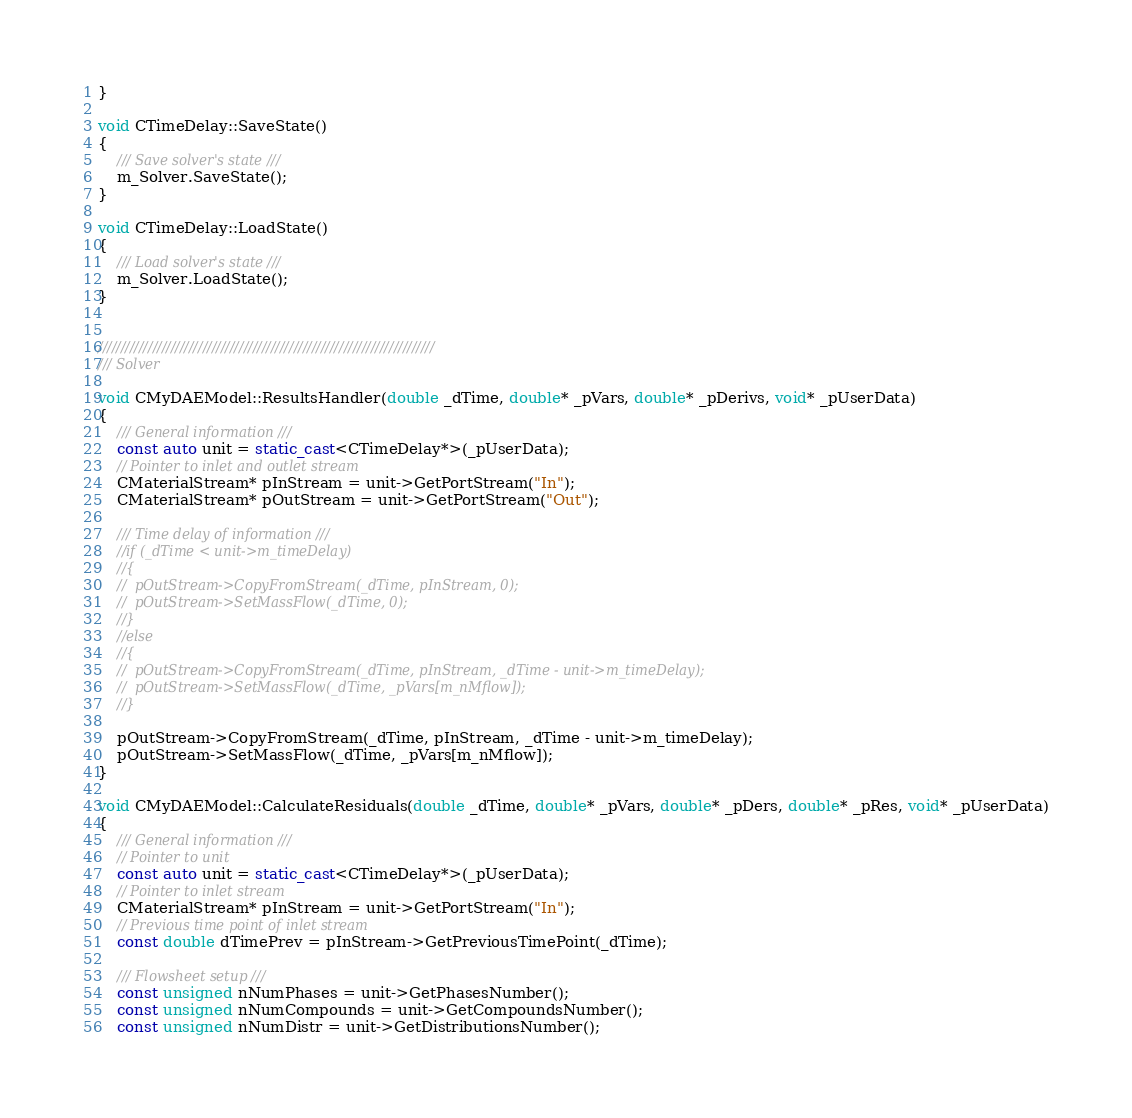Convert code to text. <code><loc_0><loc_0><loc_500><loc_500><_C++_>}

void CTimeDelay::SaveState()
{
	/// Save solver's state ///
	m_Solver.SaveState();
}

void CTimeDelay::LoadState()
{
	/// Load solver's state ///
	m_Solver.LoadState();
}


//////////////////////////////////////////////////////////////////////////
/// Solver

void CMyDAEModel::ResultsHandler(double _dTime, double* _pVars, double* _pDerivs, void* _pUserData)
{
	/// General information ///
	const auto unit = static_cast<CTimeDelay*>(_pUserData);
	// Pointer to inlet and outlet stream
	CMaterialStream* pInStream = unit->GetPortStream("In");
	CMaterialStream* pOutStream = unit->GetPortStream("Out");

	/// Time delay of information ///
	//if (_dTime < unit->m_timeDelay)
	//{
	//	pOutStream->CopyFromStream(_dTime, pInStream, 0);
	//	pOutStream->SetMassFlow(_dTime, 0);
	//}
	//else
	//{
	//	pOutStream->CopyFromStream(_dTime, pInStream, _dTime - unit->m_timeDelay);
	//	pOutStream->SetMassFlow(_dTime, _pVars[m_nMflow]);
	//}

	pOutStream->CopyFromStream(_dTime, pInStream, _dTime - unit->m_timeDelay);
	pOutStream->SetMassFlow(_dTime, _pVars[m_nMflow]);
}

void CMyDAEModel::CalculateResiduals(double _dTime, double* _pVars, double* _pDers, double* _pRes, void* _pUserData)
{
	/// General information ///
	// Pointer to unit
	const auto unit = static_cast<CTimeDelay*>(_pUserData);
	// Pointer to inlet stream
	CMaterialStream* pInStream = unit->GetPortStream("In");
	// Previous time point of inlet stream
	const double dTimePrev = pInStream->GetPreviousTimePoint(_dTime);

	/// Flowsheet setup ///
	const unsigned nNumPhases = unit->GetPhasesNumber();
	const unsigned nNumCompounds = unit->GetCompoundsNumber();
	const unsigned nNumDistr = unit->GetDistributionsNumber();</code> 